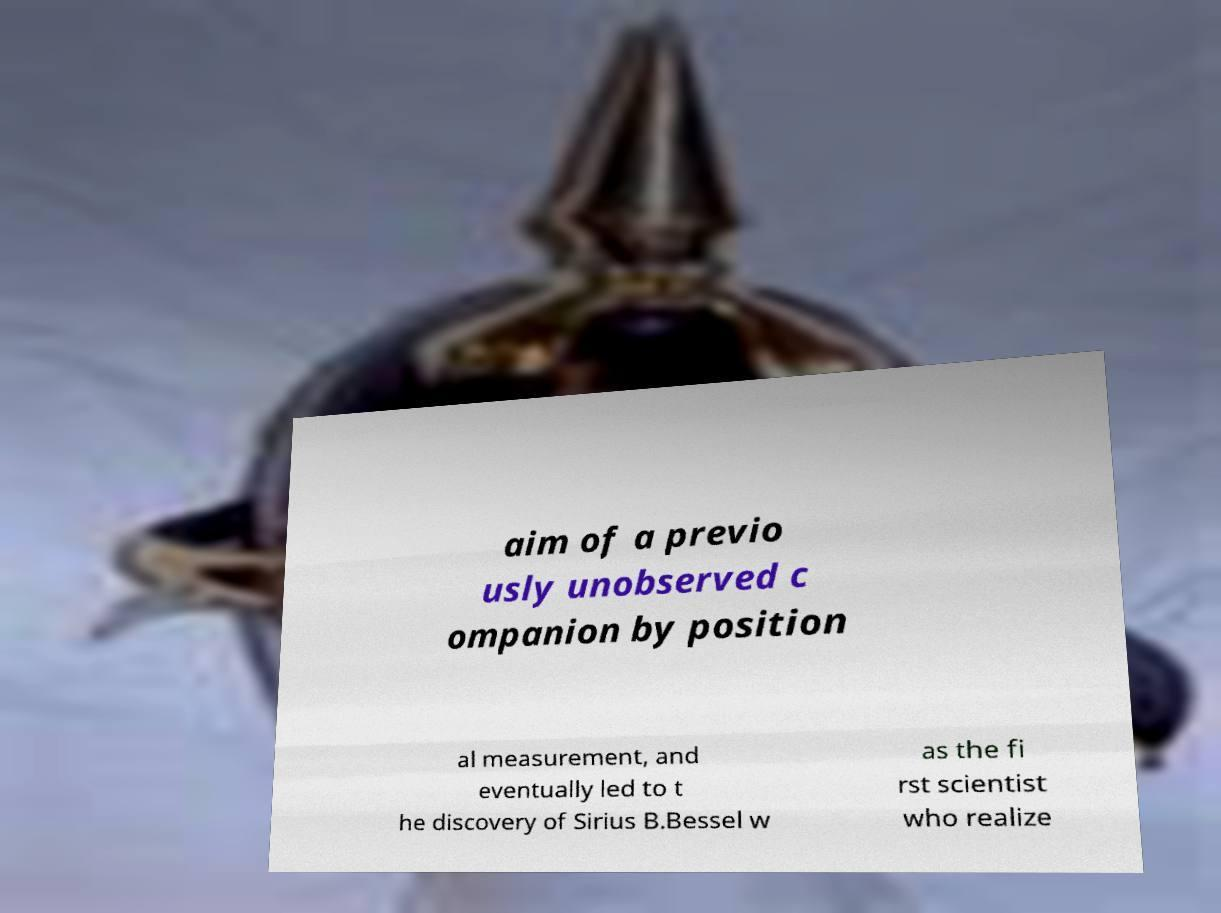Can you read and provide the text displayed in the image?This photo seems to have some interesting text. Can you extract and type it out for me? aim of a previo usly unobserved c ompanion by position al measurement, and eventually led to t he discovery of Sirius B.Bessel w as the fi rst scientist who realize 